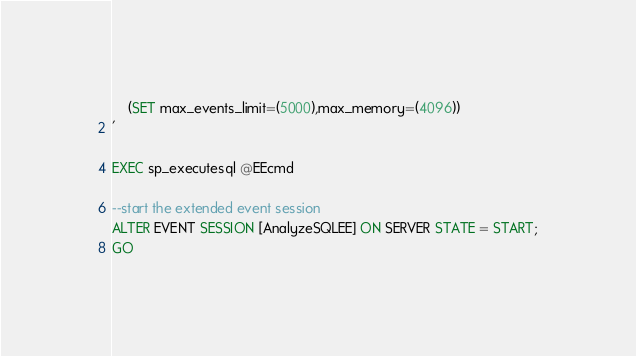Convert code to text. <code><loc_0><loc_0><loc_500><loc_500><_SQL_>	(SET max_events_limit=(5000),max_memory=(4096))
'

EXEC sp_executesql @EEcmd

--start the extended event session
ALTER EVENT SESSION [AnalyzeSQLEE] ON SERVER STATE = START;
GO</code> 